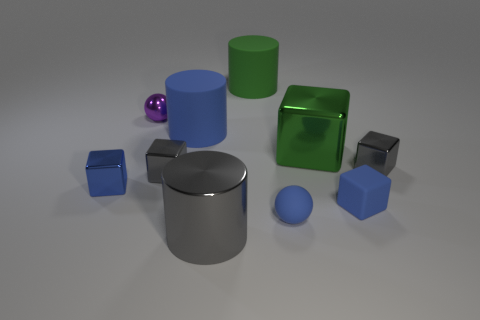What does the arrangement of these objects in the image suggest about their purpose or context? The arrangement of the objects in the image seems to be random, with no particular pattern or order. This suggests they may be placed for display or as part of an artistic composition. They might also be used for a visual study of shapes, colors, and materials, possibly in a 3D modeling or rendering context to showcase different textures and lighting effects. 